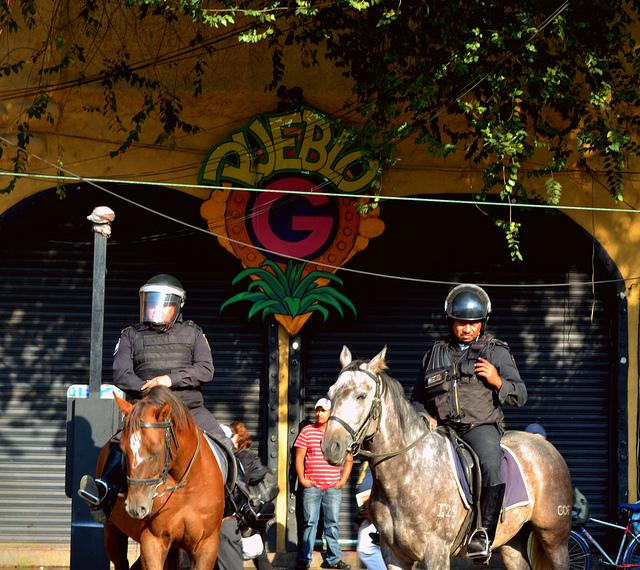What is the profession of the men on horses? Please explain your reasoning. officer. The men are wearing tactical gear, uniforms, and badges. 